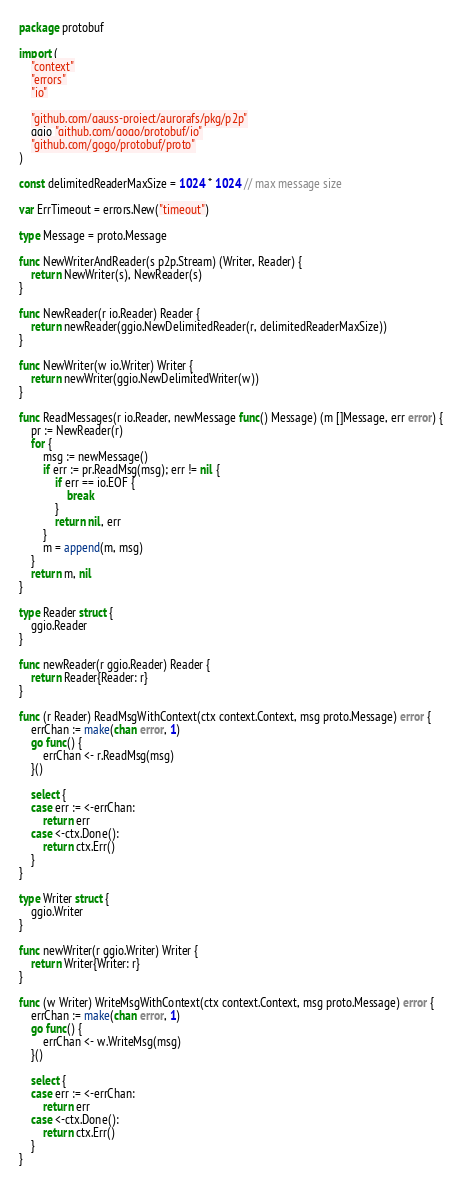Convert code to text. <code><loc_0><loc_0><loc_500><loc_500><_Go_>package protobuf

import (
	"context"
	"errors"
	"io"

	"github.com/gauss-project/aurorafs/pkg/p2p"
	ggio "github.com/gogo/protobuf/io"
	"github.com/gogo/protobuf/proto"
)

const delimitedReaderMaxSize = 1024 * 1024 // max message size

var ErrTimeout = errors.New("timeout")

type Message = proto.Message

func NewWriterAndReader(s p2p.Stream) (Writer, Reader) {
	return NewWriter(s), NewReader(s)
}

func NewReader(r io.Reader) Reader {
	return newReader(ggio.NewDelimitedReader(r, delimitedReaderMaxSize))
}

func NewWriter(w io.Writer) Writer {
	return newWriter(ggio.NewDelimitedWriter(w))
}

func ReadMessages(r io.Reader, newMessage func() Message) (m []Message, err error) {
	pr := NewReader(r)
	for {
		msg := newMessage()
		if err := pr.ReadMsg(msg); err != nil {
			if err == io.EOF {
				break
			}
			return nil, err
		}
		m = append(m, msg)
	}
	return m, nil
}

type Reader struct {
	ggio.Reader
}

func newReader(r ggio.Reader) Reader {
	return Reader{Reader: r}
}

func (r Reader) ReadMsgWithContext(ctx context.Context, msg proto.Message) error {
	errChan := make(chan error, 1)
	go func() {
		errChan <- r.ReadMsg(msg)
	}()

	select {
	case err := <-errChan:
		return err
	case <-ctx.Done():
		return ctx.Err()
	}
}

type Writer struct {
	ggio.Writer
}

func newWriter(r ggio.Writer) Writer {
	return Writer{Writer: r}
}

func (w Writer) WriteMsgWithContext(ctx context.Context, msg proto.Message) error {
	errChan := make(chan error, 1)
	go func() {
		errChan <- w.WriteMsg(msg)
	}()

	select {
	case err := <-errChan:
		return err
	case <-ctx.Done():
		return ctx.Err()
	}
}
</code> 